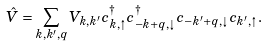Convert formula to latex. <formula><loc_0><loc_0><loc_500><loc_500>\hat { V } = \sum _ { { k } , { k ^ { \prime } } , { q } } V _ { { k } , { k ^ { \prime } } } c ^ { \dagger } _ { { k } , \uparrow } c ^ { \dagger } _ { { - k } + { q } , \downarrow } c _ { { - k ^ { \prime } } + { q } , \downarrow } c _ { { k ^ { \prime } } , \uparrow } .</formula> 